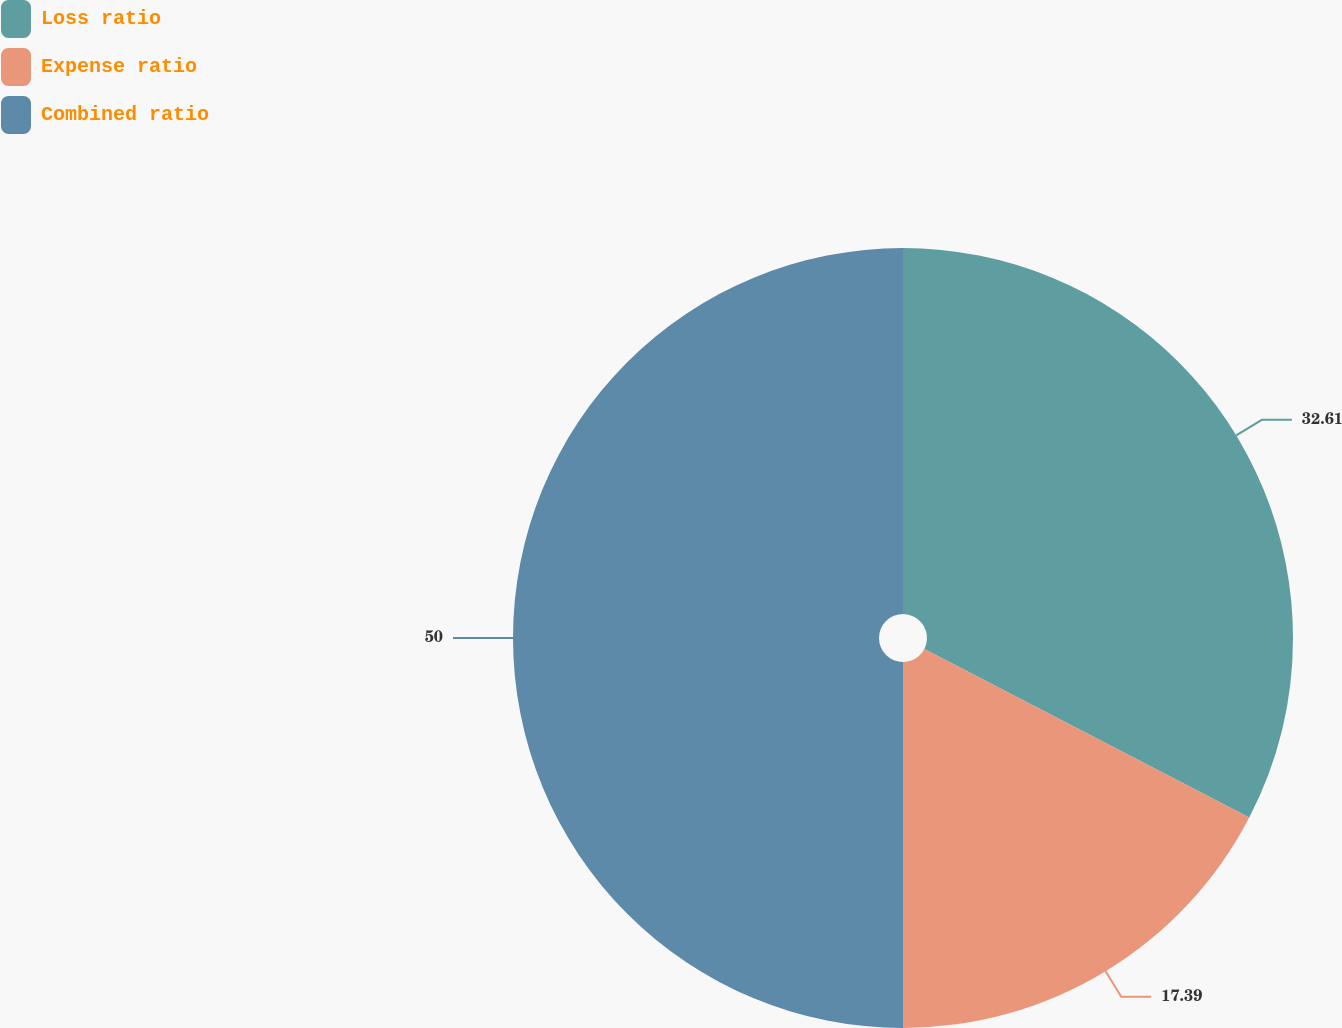<chart> <loc_0><loc_0><loc_500><loc_500><pie_chart><fcel>Loss ratio<fcel>Expense ratio<fcel>Combined ratio<nl><fcel>32.61%<fcel>17.39%<fcel>50.0%<nl></chart> 